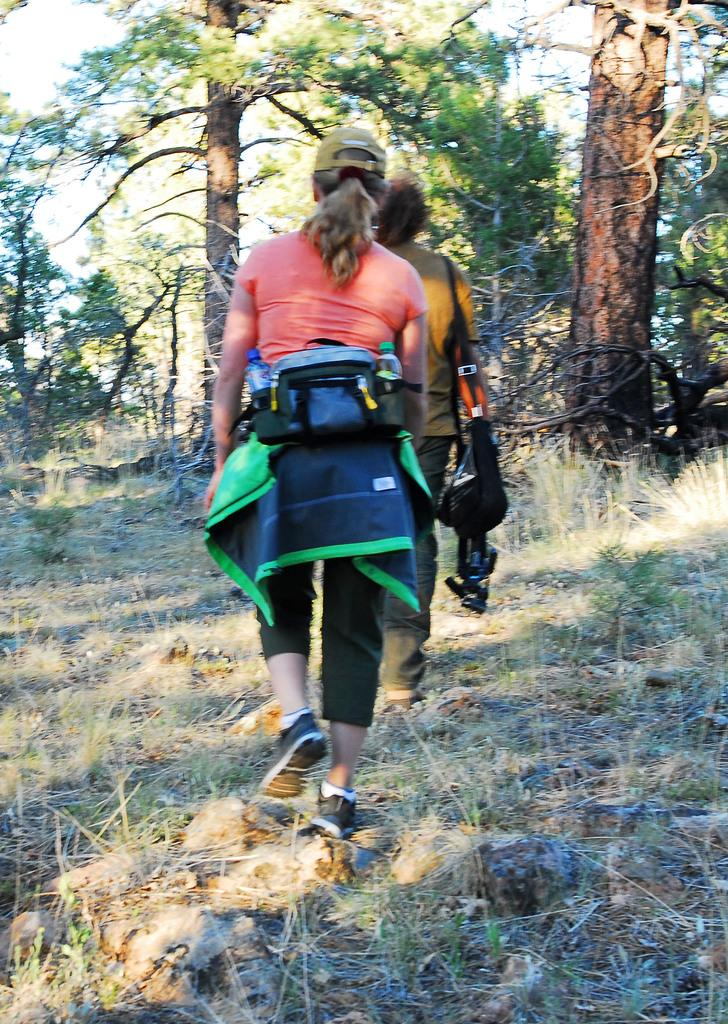How many people are in the image? There are two persons in the image. What are the persons doing in the image? The persons are walking. What type of natural environment can be seen in the image? There are trees in the image. What type of bait is being used by the persons in the image? There is no bait present in the image; the persons are simply walking. What type of planes can be seen flying in the image? There are no planes visible in the image. 